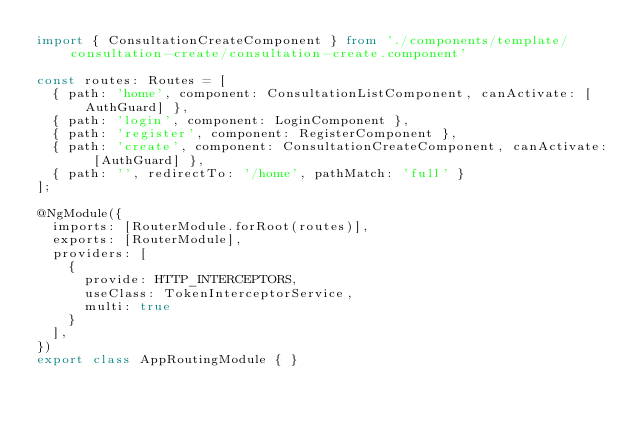<code> <loc_0><loc_0><loc_500><loc_500><_TypeScript_>import { ConsultationCreateComponent } from './components/template/consultation-create/consultation-create.component'

const routes: Routes = [
  { path: 'home', component: ConsultationListComponent, canActivate: [AuthGuard] },
  { path: 'login', component: LoginComponent },
  { path: 'register', component: RegisterComponent },
  { path: 'create', component: ConsultationCreateComponent, canActivate: [AuthGuard] },
  { path: '', redirectTo: '/home', pathMatch: 'full' }
];

@NgModule({
  imports: [RouterModule.forRoot(routes)],
  exports: [RouterModule],
  providers: [
    {
      provide: HTTP_INTERCEPTORS,
      useClass: TokenInterceptorService,
      multi: true
    }
  ],
})
export class AppRoutingModule { }
</code> 